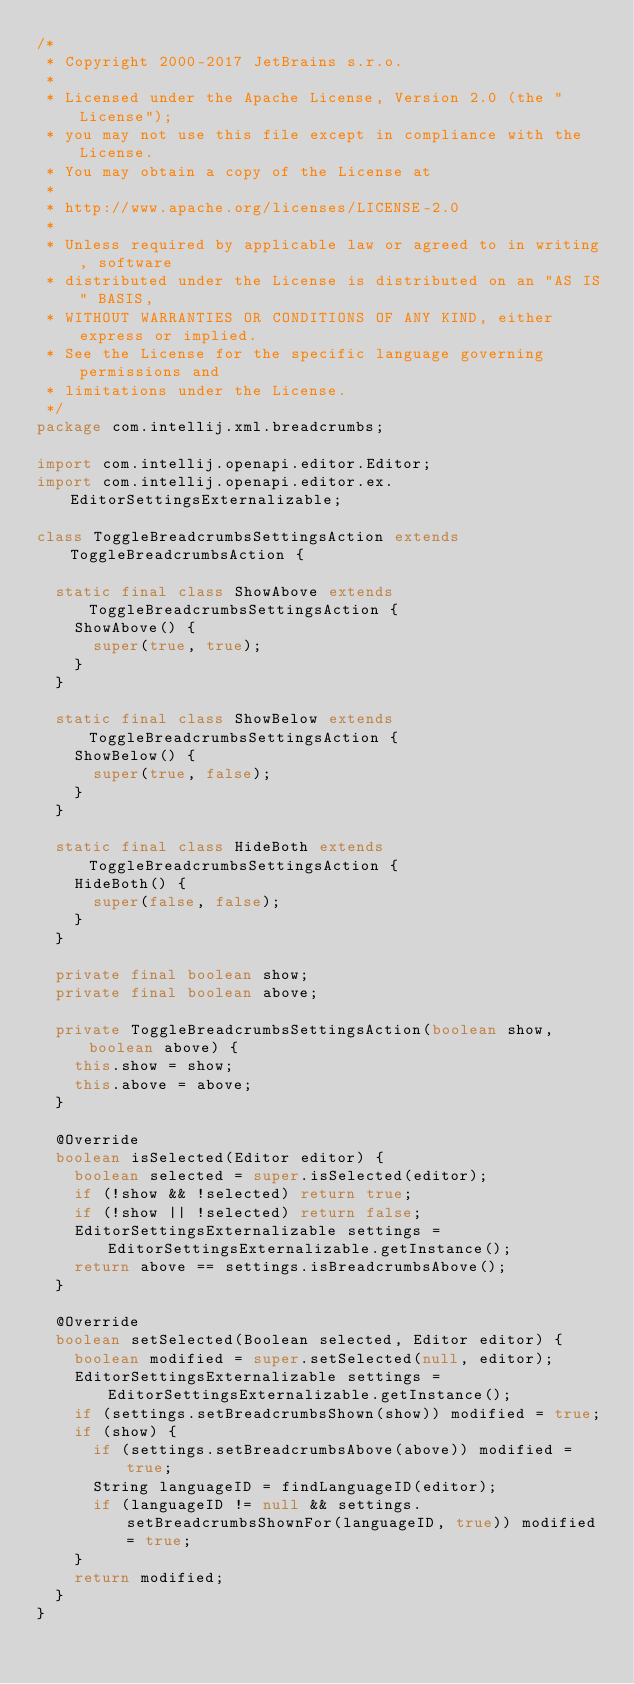<code> <loc_0><loc_0><loc_500><loc_500><_Java_>/*
 * Copyright 2000-2017 JetBrains s.r.o.
 *
 * Licensed under the Apache License, Version 2.0 (the "License");
 * you may not use this file except in compliance with the License.
 * You may obtain a copy of the License at
 *
 * http://www.apache.org/licenses/LICENSE-2.0
 *
 * Unless required by applicable law or agreed to in writing, software
 * distributed under the License is distributed on an "AS IS" BASIS,
 * WITHOUT WARRANTIES OR CONDITIONS OF ANY KIND, either express or implied.
 * See the License for the specific language governing permissions and
 * limitations under the License.
 */
package com.intellij.xml.breadcrumbs;

import com.intellij.openapi.editor.Editor;
import com.intellij.openapi.editor.ex.EditorSettingsExternalizable;

class ToggleBreadcrumbsSettingsAction extends ToggleBreadcrumbsAction {

  static final class ShowAbove extends ToggleBreadcrumbsSettingsAction {
    ShowAbove() {
      super(true, true);
    }
  }

  static final class ShowBelow extends ToggleBreadcrumbsSettingsAction {
    ShowBelow() {
      super(true, false);
    }
  }

  static final class HideBoth extends ToggleBreadcrumbsSettingsAction {
    HideBoth() {
      super(false, false);
    }
  }

  private final boolean show;
  private final boolean above;

  private ToggleBreadcrumbsSettingsAction(boolean show, boolean above) {
    this.show = show;
    this.above = above;
  }

  @Override
  boolean isSelected(Editor editor) {
    boolean selected = super.isSelected(editor);
    if (!show && !selected) return true;
    if (!show || !selected) return false;
    EditorSettingsExternalizable settings = EditorSettingsExternalizable.getInstance();
    return above == settings.isBreadcrumbsAbove();
  }

  @Override
  boolean setSelected(Boolean selected, Editor editor) {
    boolean modified = super.setSelected(null, editor);
    EditorSettingsExternalizable settings = EditorSettingsExternalizable.getInstance();
    if (settings.setBreadcrumbsShown(show)) modified = true;
    if (show) {
      if (settings.setBreadcrumbsAbove(above)) modified = true;
      String languageID = findLanguageID(editor);
      if (languageID != null && settings.setBreadcrumbsShownFor(languageID, true)) modified = true;
    }
    return modified;
  }
}
</code> 